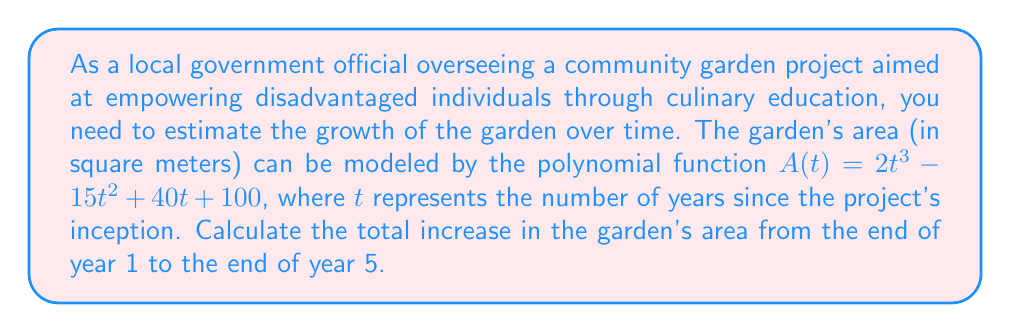Solve this math problem. To solve this problem, we need to follow these steps:

1. Calculate the area at the end of year 1:
   $A(1) = 2(1)^3 - 15(1)^2 + 40(1) + 100$
   $A(1) = 2 - 15 + 40 + 100 = 127$ square meters

2. Calculate the area at the end of year 5:
   $A(5) = 2(5)^3 - 15(5)^2 + 40(5) + 100$
   $A(5) = 2(125) - 15(25) + 40(5) + 100$
   $A(5) = 250 - 375 + 200 + 100 = 175$ square meters

3. Calculate the total increase by subtracting the area at year 1 from the area at year 5:
   Increase = $A(5) - A(1) = 175 - 127 = 48$ square meters

Therefore, the total increase in the garden's area from the end of year 1 to the end of year 5 is 48 square meters.
Answer: 48 square meters 